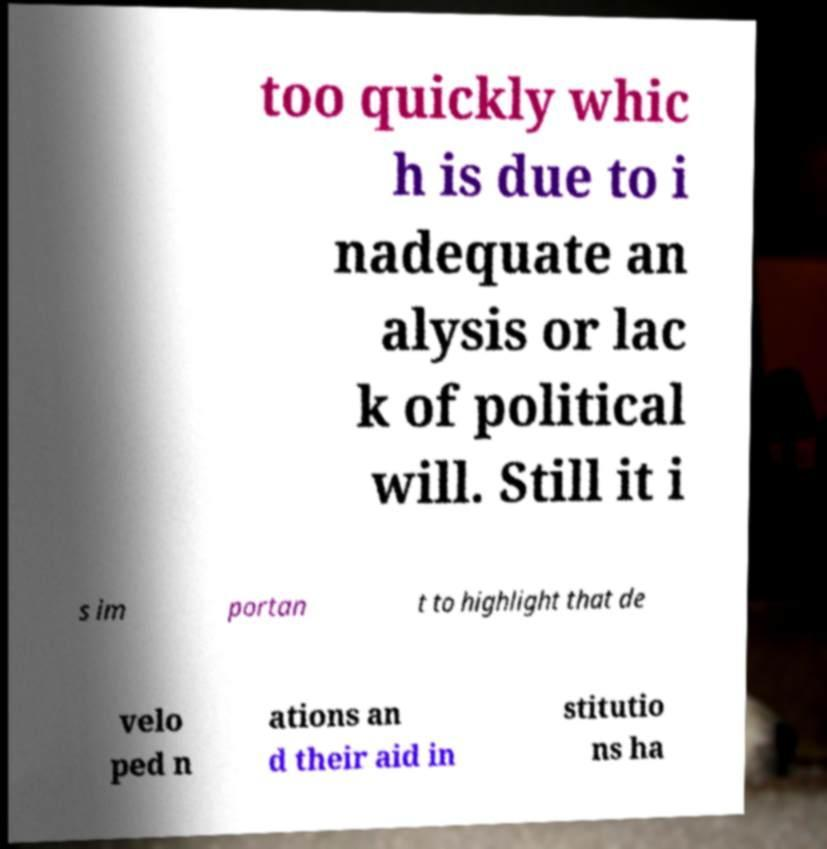Please identify and transcribe the text found in this image. too quickly whic h is due to i nadequate an alysis or lac k of political will. Still it i s im portan t to highlight that de velo ped n ations an d their aid in stitutio ns ha 